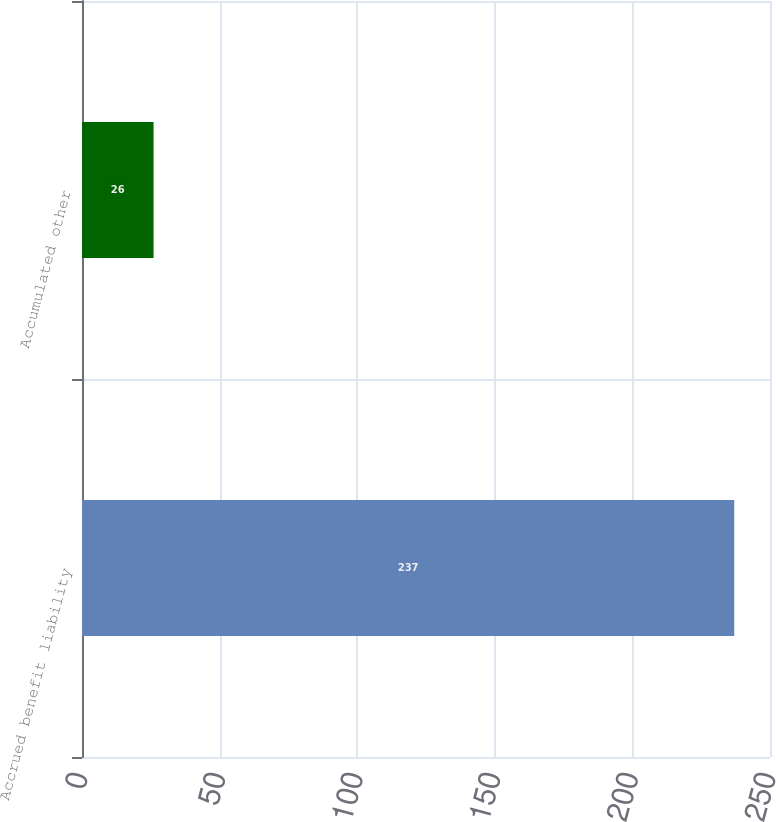<chart> <loc_0><loc_0><loc_500><loc_500><bar_chart><fcel>Accrued benefit liability<fcel>Accumulated other<nl><fcel>237<fcel>26<nl></chart> 